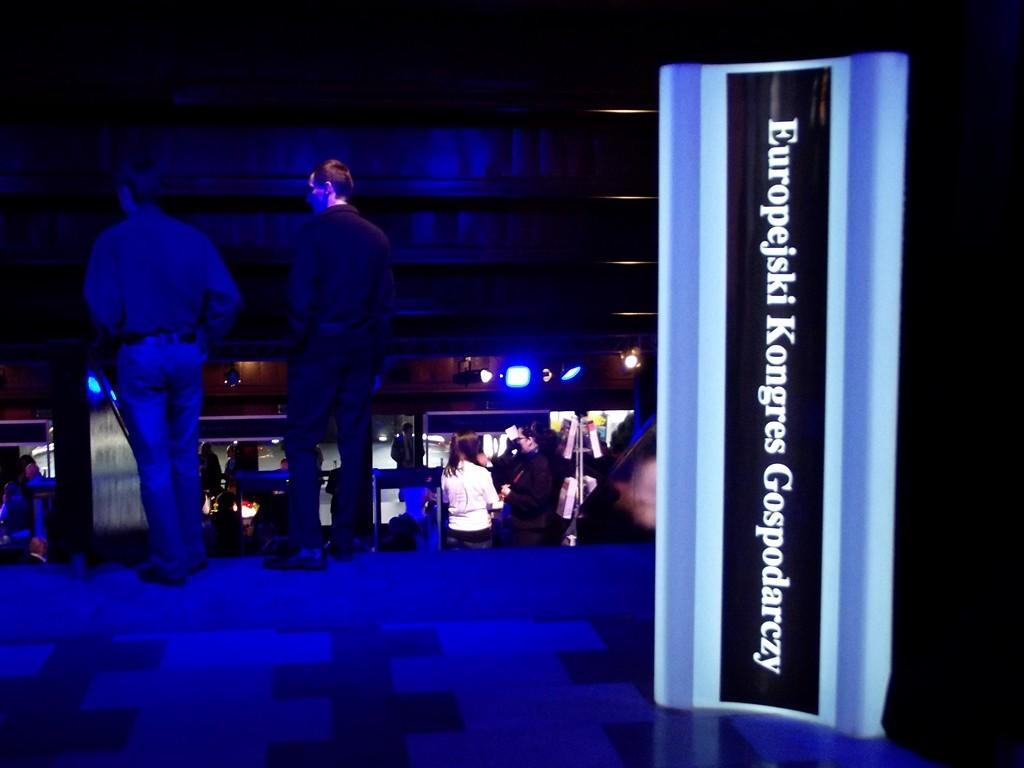In one or two sentences, can you explain what this image depicts? In the image there is a label on an object, behind that label there are two men and under them there are few other people standing and there are blue lights fixed to the wall. 